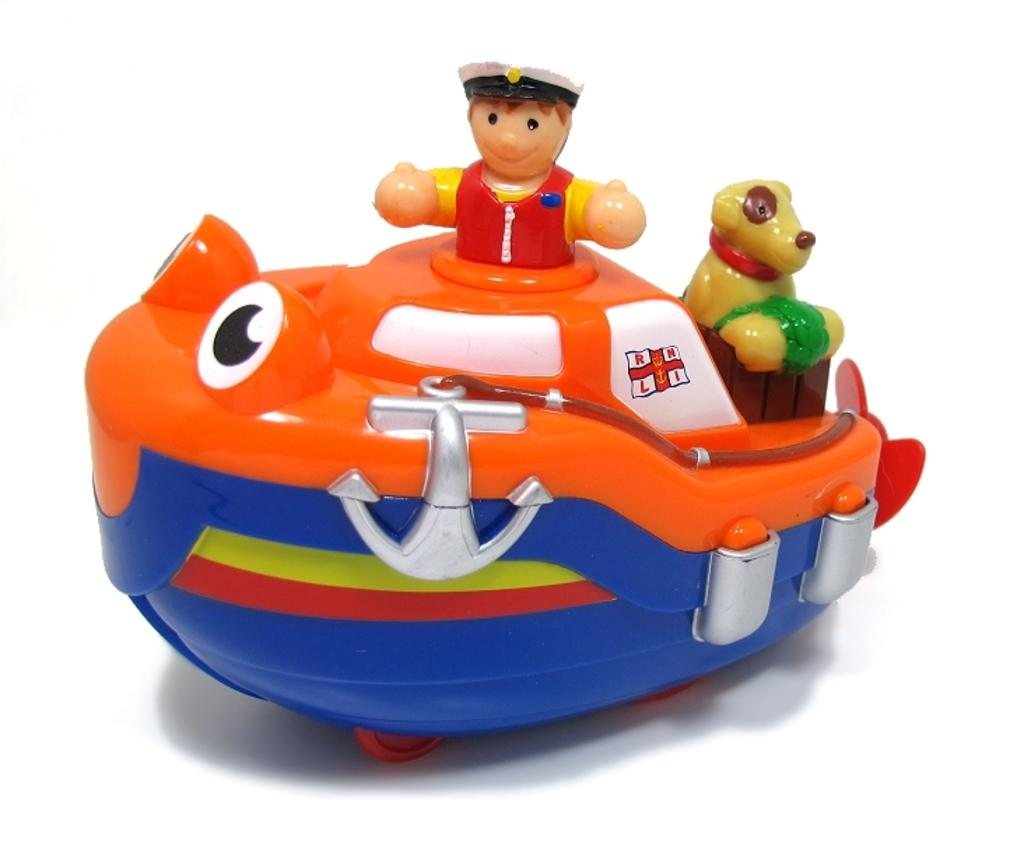What object in the image is designed for play or entertainment? There is a toy in the image. What type of milk is being poured into the toy in the image? There is no milk or pouring action present in the image; it only features a toy. 